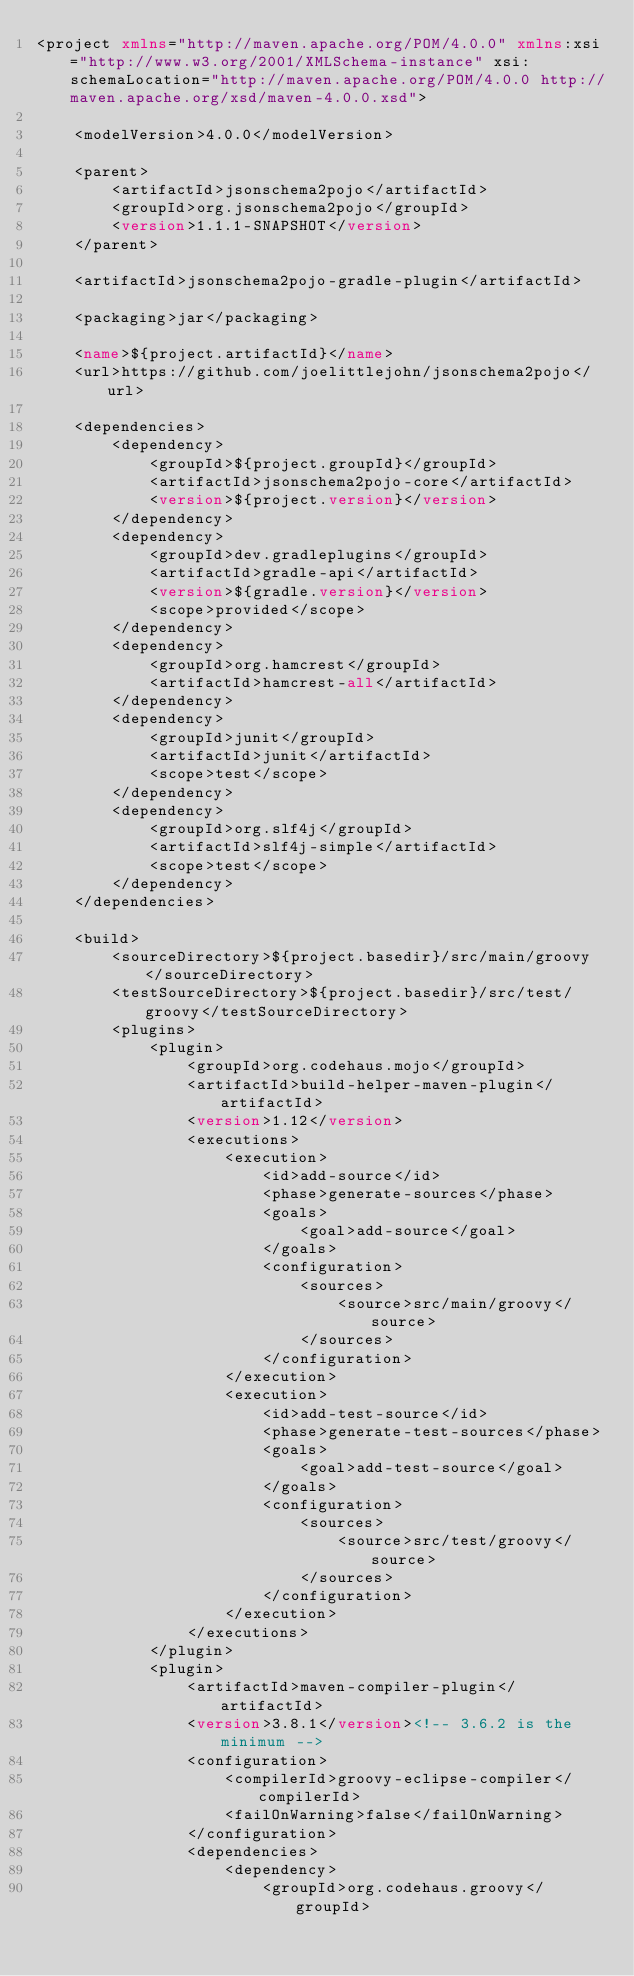Convert code to text. <code><loc_0><loc_0><loc_500><loc_500><_XML_><project xmlns="http://maven.apache.org/POM/4.0.0" xmlns:xsi="http://www.w3.org/2001/XMLSchema-instance" xsi:schemaLocation="http://maven.apache.org/POM/4.0.0 http://maven.apache.org/xsd/maven-4.0.0.xsd">

    <modelVersion>4.0.0</modelVersion>

    <parent>
        <artifactId>jsonschema2pojo</artifactId>
        <groupId>org.jsonschema2pojo</groupId>
        <version>1.1.1-SNAPSHOT</version>
    </parent>

    <artifactId>jsonschema2pojo-gradle-plugin</artifactId>

    <packaging>jar</packaging>

    <name>${project.artifactId}</name>
    <url>https://github.com/joelittlejohn/jsonschema2pojo</url>

    <dependencies>
        <dependency>
            <groupId>${project.groupId}</groupId>
            <artifactId>jsonschema2pojo-core</artifactId>
            <version>${project.version}</version>
        </dependency>
        <dependency>
            <groupId>dev.gradleplugins</groupId>
            <artifactId>gradle-api</artifactId>
            <version>${gradle.version}</version>
            <scope>provided</scope>
        </dependency>
        <dependency>
            <groupId>org.hamcrest</groupId>
            <artifactId>hamcrest-all</artifactId>
        </dependency>
        <dependency>
            <groupId>junit</groupId>
            <artifactId>junit</artifactId>
            <scope>test</scope>
        </dependency>
        <dependency>
            <groupId>org.slf4j</groupId>
            <artifactId>slf4j-simple</artifactId>
            <scope>test</scope>
        </dependency>
    </dependencies>

    <build>
        <sourceDirectory>${project.basedir}/src/main/groovy</sourceDirectory>
        <testSourceDirectory>${project.basedir}/src/test/groovy</testSourceDirectory>
        <plugins>
            <plugin>
                <groupId>org.codehaus.mojo</groupId>
                <artifactId>build-helper-maven-plugin</artifactId>
                <version>1.12</version>
                <executions>
                    <execution>
                        <id>add-source</id>
                        <phase>generate-sources</phase>
                        <goals>
                            <goal>add-source</goal>
                        </goals>
                        <configuration>
                            <sources>
                                <source>src/main/groovy</source>
                            </sources>
                        </configuration>
                    </execution>
                    <execution>
                        <id>add-test-source</id>
                        <phase>generate-test-sources</phase>
                        <goals>
                            <goal>add-test-source</goal>
                        </goals>
                        <configuration>
                            <sources>
                                <source>src/test/groovy</source>
                            </sources>
                        </configuration>
                    </execution>
                </executions>
            </plugin>
            <plugin>
                <artifactId>maven-compiler-plugin</artifactId>
                <version>3.8.1</version><!-- 3.6.2 is the minimum -->
                <configuration>
                    <compilerId>groovy-eclipse-compiler</compilerId>
                    <failOnWarning>false</failOnWarning>
                </configuration>
                <dependencies>
                    <dependency>
                        <groupId>org.codehaus.groovy</groupId></code> 